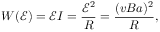Convert formula to latex. <formula><loc_0><loc_0><loc_500><loc_500>W ( \mathcal { E } ) = \mathcal { E } I = \frac { \mathcal { E } ^ { 2 } } { R } = \frac { ( v B a ) ^ { 2 } } { R } ,</formula> 